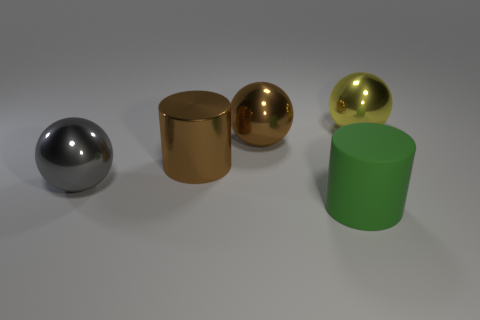Add 4 small gray matte cubes. How many objects exist? 9 Subtract all yellow balls. How many balls are left? 2 Subtract all cylinders. How many objects are left? 3 Subtract 2 balls. How many balls are left? 1 Subtract all big gray balls. Subtract all shiny balls. How many objects are left? 1 Add 1 yellow balls. How many yellow balls are left? 2 Add 5 purple matte cylinders. How many purple matte cylinders exist? 5 Subtract 0 blue blocks. How many objects are left? 5 Subtract all gray cylinders. Subtract all yellow blocks. How many cylinders are left? 2 